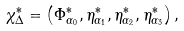<formula> <loc_0><loc_0><loc_500><loc_500>\chi _ { \Delta } ^ { \ast } = \left ( \Phi _ { \alpha _ { 0 } } ^ { \ast } , \eta _ { \alpha _ { 1 } } ^ { \ast } , \eta _ { \alpha _ { 2 } } ^ { \ast } , \eta _ { \alpha _ { 3 } } ^ { \ast } \right ) ,</formula> 